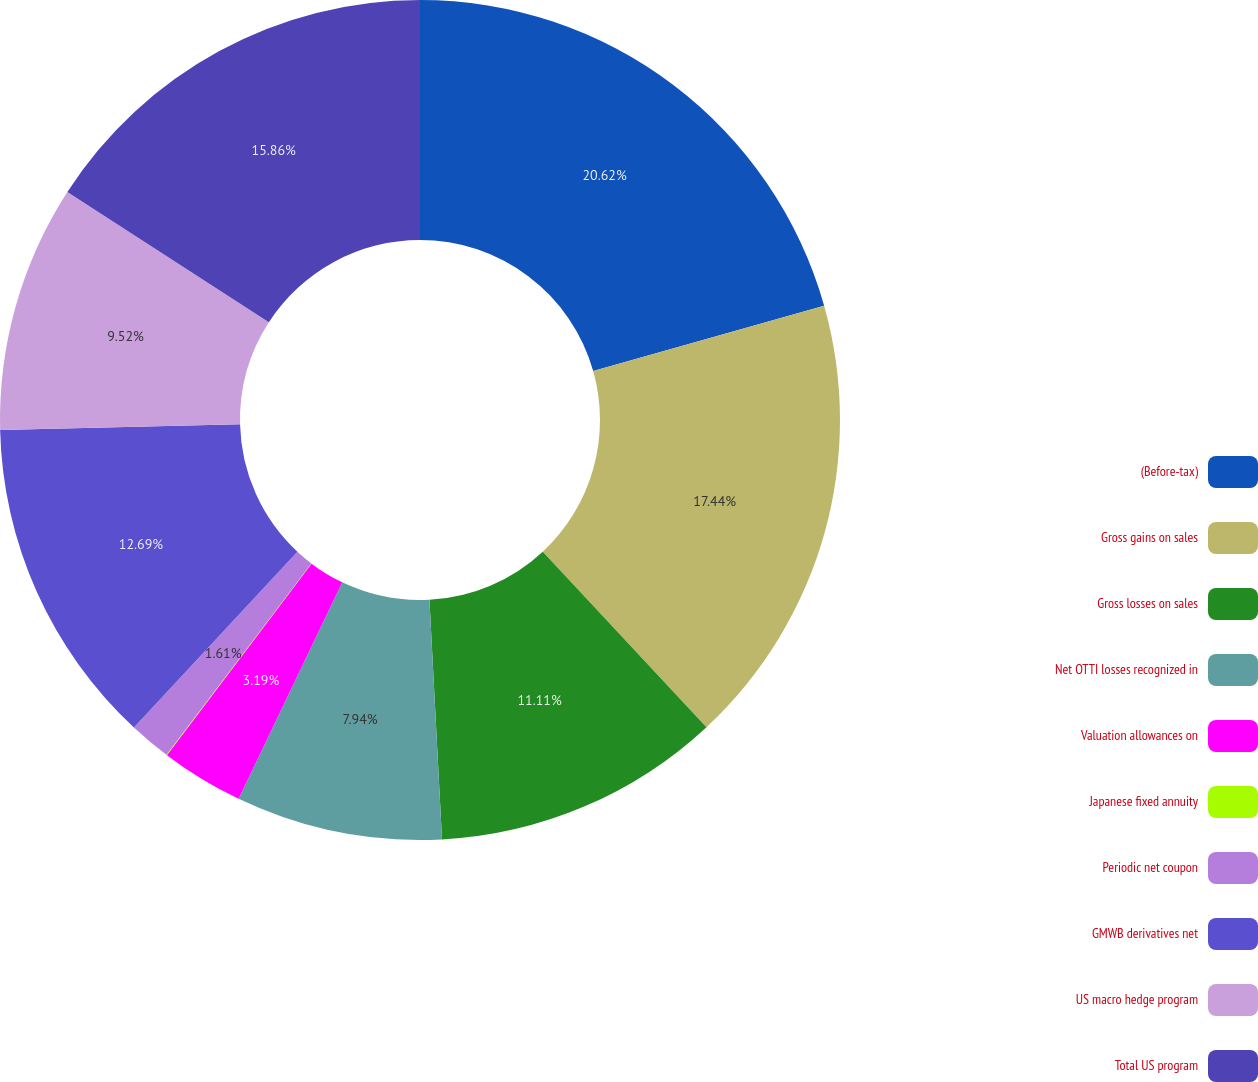Convert chart. <chart><loc_0><loc_0><loc_500><loc_500><pie_chart><fcel>(Before-tax)<fcel>Gross gains on sales<fcel>Gross losses on sales<fcel>Net OTTI losses recognized in<fcel>Valuation allowances on<fcel>Japanese fixed annuity<fcel>Periodic net coupon<fcel>GMWB derivatives net<fcel>US macro hedge program<fcel>Total US program<nl><fcel>20.61%<fcel>17.44%<fcel>11.11%<fcel>7.94%<fcel>3.19%<fcel>0.02%<fcel>1.61%<fcel>12.69%<fcel>9.52%<fcel>15.86%<nl></chart> 